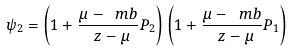Convert formula to latex. <formula><loc_0><loc_0><loc_500><loc_500>\psi _ { 2 } = \left ( 1 + \frac { \mu - \ m b } { \ z - \mu } P _ { 2 } \right ) \left ( 1 + \frac { \mu - \ m b } { \ z - \mu } P _ { 1 } \right )</formula> 